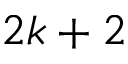<formula> <loc_0><loc_0><loc_500><loc_500>2 k + 2</formula> 